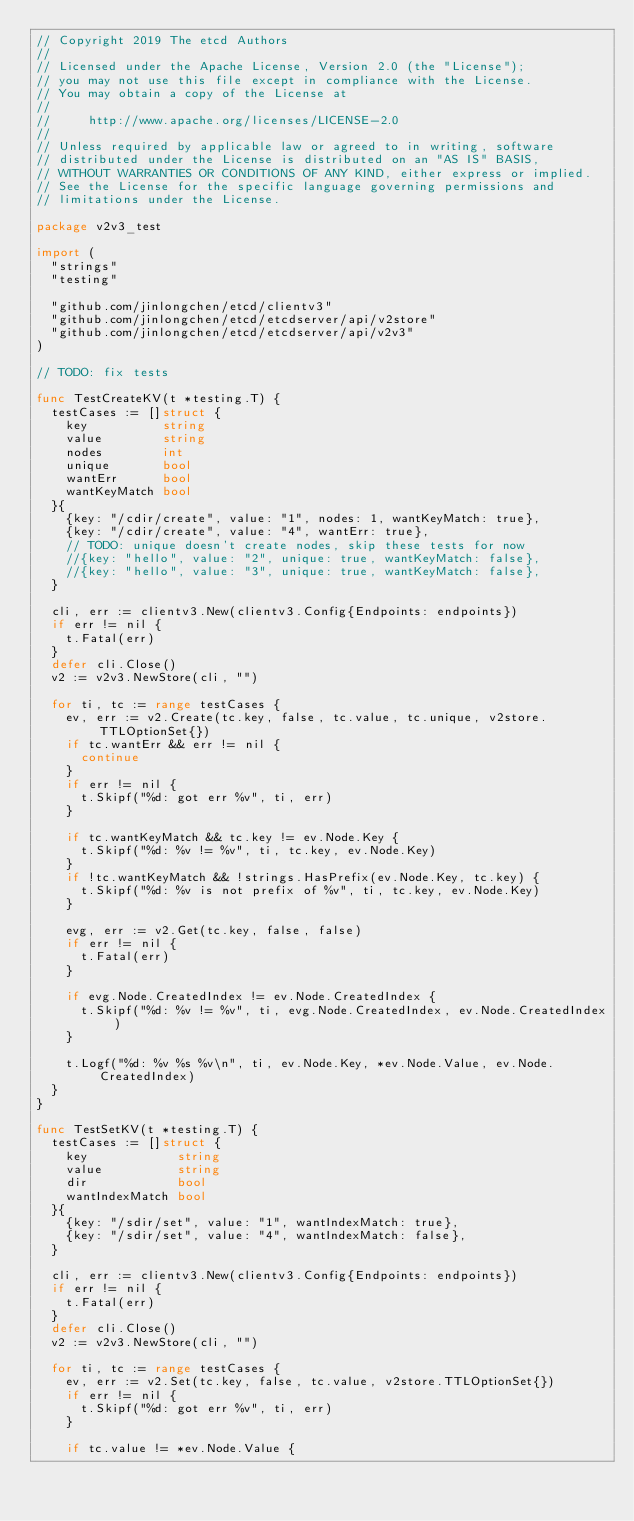<code> <loc_0><loc_0><loc_500><loc_500><_Go_>// Copyright 2019 The etcd Authors
//
// Licensed under the Apache License, Version 2.0 (the "License");
// you may not use this file except in compliance with the License.
// You may obtain a copy of the License at
//
//     http://www.apache.org/licenses/LICENSE-2.0
//
// Unless required by applicable law or agreed to in writing, software
// distributed under the License is distributed on an "AS IS" BASIS,
// WITHOUT WARRANTIES OR CONDITIONS OF ANY KIND, either express or implied.
// See the License for the specific language governing permissions and
// limitations under the License.

package v2v3_test

import (
	"strings"
	"testing"

	"github.com/jinlongchen/etcd/clientv3"
	"github.com/jinlongchen/etcd/etcdserver/api/v2store"
	"github.com/jinlongchen/etcd/etcdserver/api/v2v3"
)

// TODO: fix tests

func TestCreateKV(t *testing.T) {
	testCases := []struct {
		key          string
		value        string
		nodes        int
		unique       bool
		wantErr      bool
		wantKeyMatch bool
	}{
		{key: "/cdir/create", value: "1", nodes: 1, wantKeyMatch: true},
		{key: "/cdir/create", value: "4", wantErr: true},
		// TODO: unique doesn't create nodes, skip these tests for now
		//{key: "hello", value: "2", unique: true, wantKeyMatch: false},
		//{key: "hello", value: "3", unique: true, wantKeyMatch: false},
	}

	cli, err := clientv3.New(clientv3.Config{Endpoints: endpoints})
	if err != nil {
		t.Fatal(err)
	}
	defer cli.Close()
	v2 := v2v3.NewStore(cli, "")

	for ti, tc := range testCases {
		ev, err := v2.Create(tc.key, false, tc.value, tc.unique, v2store.TTLOptionSet{})
		if tc.wantErr && err != nil {
			continue
		}
		if err != nil {
			t.Skipf("%d: got err %v", ti, err)
		}

		if tc.wantKeyMatch && tc.key != ev.Node.Key {
			t.Skipf("%d: %v != %v", ti, tc.key, ev.Node.Key)
		}
		if !tc.wantKeyMatch && !strings.HasPrefix(ev.Node.Key, tc.key) {
			t.Skipf("%d: %v is not prefix of %v", ti, tc.key, ev.Node.Key)
		}

		evg, err := v2.Get(tc.key, false, false)
		if err != nil {
			t.Fatal(err)
		}

		if evg.Node.CreatedIndex != ev.Node.CreatedIndex {
			t.Skipf("%d: %v != %v", ti, evg.Node.CreatedIndex, ev.Node.CreatedIndex)
		}

		t.Logf("%d: %v %s %v\n", ti, ev.Node.Key, *ev.Node.Value, ev.Node.CreatedIndex)
	}
}

func TestSetKV(t *testing.T) {
	testCases := []struct {
		key            string
		value          string
		dir            bool
		wantIndexMatch bool
	}{
		{key: "/sdir/set", value: "1", wantIndexMatch: true},
		{key: "/sdir/set", value: "4", wantIndexMatch: false},
	}

	cli, err := clientv3.New(clientv3.Config{Endpoints: endpoints})
	if err != nil {
		t.Fatal(err)
	}
	defer cli.Close()
	v2 := v2v3.NewStore(cli, "")

	for ti, tc := range testCases {
		ev, err := v2.Set(tc.key, false, tc.value, v2store.TTLOptionSet{})
		if err != nil {
			t.Skipf("%d: got err %v", ti, err)
		}

		if tc.value != *ev.Node.Value {</code> 